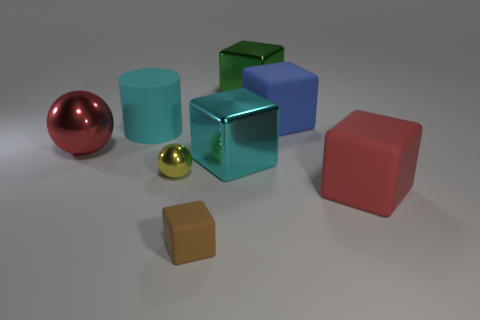Is the tiny block the same color as the cylinder?
Ensure brevity in your answer.  No. What number of rubber blocks are the same color as the large sphere?
Make the answer very short. 1. There is a small ball that is in front of the large red ball; is it the same color as the big cylinder?
Provide a short and direct response. No. Are there an equal number of cyan matte objects on the left side of the rubber cylinder and large red rubber cubes that are behind the small yellow shiny thing?
Offer a very short reply. Yes. Is there any other thing that has the same material as the cylinder?
Offer a terse response. Yes. What color is the large rubber object that is left of the tiny rubber object?
Make the answer very short. Cyan. Is the number of large shiny balls on the right side of the cylinder the same as the number of small purple metal blocks?
Your response must be concise. Yes. What number of other objects are the same shape as the yellow object?
Offer a terse response. 1. What number of big cyan shiny blocks are right of the brown rubber block?
Give a very brief answer. 1. What is the size of the matte block that is both in front of the small shiny thing and to the right of the small brown matte thing?
Your answer should be very brief. Large. 